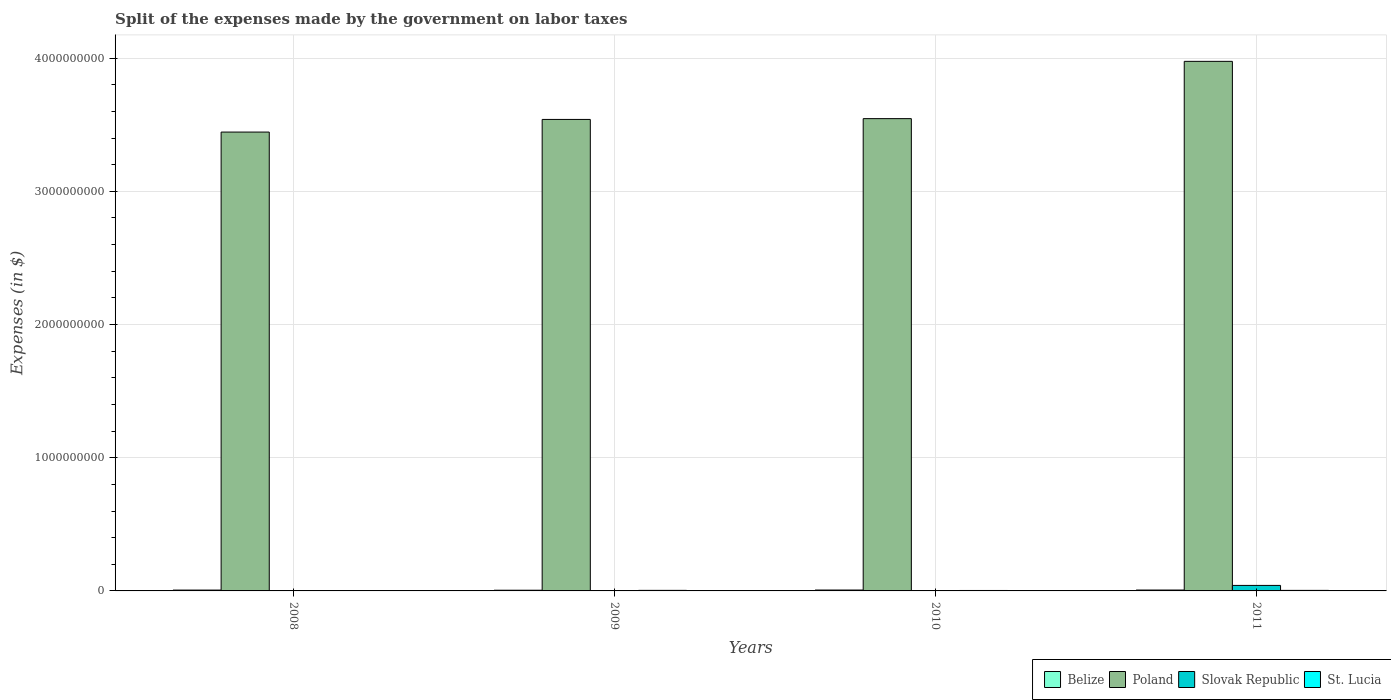Are the number of bars per tick equal to the number of legend labels?
Make the answer very short. Yes. How many bars are there on the 4th tick from the left?
Ensure brevity in your answer.  4. What is the label of the 4th group of bars from the left?
Offer a very short reply. 2011. What is the expenses made by the government on labor taxes in St. Lucia in 2008?
Offer a very short reply. 2.30e+06. Across all years, what is the maximum expenses made by the government on labor taxes in Slovak Republic?
Give a very brief answer. 4.13e+07. Across all years, what is the minimum expenses made by the government on labor taxes in Slovak Republic?
Your answer should be very brief. 3.61e+05. What is the total expenses made by the government on labor taxes in Poland in the graph?
Your response must be concise. 1.45e+1. What is the difference between the expenses made by the government on labor taxes in Belize in 2010 and that in 2011?
Keep it short and to the point. -1.03e+05. What is the difference between the expenses made by the government on labor taxes in Slovak Republic in 2011 and the expenses made by the government on labor taxes in St. Lucia in 2009?
Provide a succinct answer. 3.71e+07. What is the average expenses made by the government on labor taxes in St. Lucia per year?
Your answer should be very brief. 3.45e+06. In the year 2008, what is the difference between the expenses made by the government on labor taxes in Slovak Republic and expenses made by the government on labor taxes in Belize?
Make the answer very short. -4.93e+06. What is the ratio of the expenses made by the government on labor taxes in St. Lucia in 2010 to that in 2011?
Your answer should be compact. 0.82. Is the expenses made by the government on labor taxes in St. Lucia in 2008 less than that in 2011?
Keep it short and to the point. Yes. Is the difference between the expenses made by the government on labor taxes in Slovak Republic in 2008 and 2010 greater than the difference between the expenses made by the government on labor taxes in Belize in 2008 and 2010?
Provide a succinct answer. Yes. What is the difference between the highest and the second highest expenses made by the government on labor taxes in Slovak Republic?
Offer a very short reply. 3.99e+07. What is the difference between the highest and the lowest expenses made by the government on labor taxes in Belize?
Your answer should be very brief. 1.41e+06. Is it the case that in every year, the sum of the expenses made by the government on labor taxes in Slovak Republic and expenses made by the government on labor taxes in Poland is greater than the sum of expenses made by the government on labor taxes in St. Lucia and expenses made by the government on labor taxes in Belize?
Ensure brevity in your answer.  Yes. What does the 4th bar from the left in 2010 represents?
Keep it short and to the point. St. Lucia. What does the 4th bar from the right in 2008 represents?
Give a very brief answer. Belize. Is it the case that in every year, the sum of the expenses made by the government on labor taxes in Poland and expenses made by the government on labor taxes in Slovak Republic is greater than the expenses made by the government on labor taxes in St. Lucia?
Your answer should be compact. Yes. How many bars are there?
Keep it short and to the point. 16. Are all the bars in the graph horizontal?
Ensure brevity in your answer.  No. How many years are there in the graph?
Offer a very short reply. 4. Does the graph contain grids?
Your answer should be compact. Yes. How many legend labels are there?
Keep it short and to the point. 4. What is the title of the graph?
Offer a terse response. Split of the expenses made by the government on labor taxes. What is the label or title of the Y-axis?
Offer a very short reply. Expenses (in $). What is the Expenses (in $) in Belize in 2008?
Your answer should be compact. 6.32e+06. What is the Expenses (in $) of Poland in 2008?
Keep it short and to the point. 3.44e+09. What is the Expenses (in $) of Slovak Republic in 2008?
Offer a terse response. 1.39e+06. What is the Expenses (in $) in St. Lucia in 2008?
Provide a succinct answer. 2.30e+06. What is the Expenses (in $) in Belize in 2009?
Ensure brevity in your answer.  5.26e+06. What is the Expenses (in $) in Poland in 2009?
Provide a succinct answer. 3.54e+09. What is the Expenses (in $) of Slovak Republic in 2009?
Your answer should be compact. 7.25e+05. What is the Expenses (in $) in St. Lucia in 2009?
Keep it short and to the point. 4.20e+06. What is the Expenses (in $) of Belize in 2010?
Make the answer very short. 6.57e+06. What is the Expenses (in $) of Poland in 2010?
Ensure brevity in your answer.  3.55e+09. What is the Expenses (in $) in Slovak Republic in 2010?
Provide a succinct answer. 3.61e+05. What is the Expenses (in $) of St. Lucia in 2010?
Offer a very short reply. 3.30e+06. What is the Expenses (in $) in Belize in 2011?
Your answer should be compact. 6.67e+06. What is the Expenses (in $) in Poland in 2011?
Your answer should be compact. 3.98e+09. What is the Expenses (in $) in Slovak Republic in 2011?
Your response must be concise. 4.13e+07. What is the Expenses (in $) in St. Lucia in 2011?
Provide a succinct answer. 4.00e+06. Across all years, what is the maximum Expenses (in $) of Belize?
Your answer should be compact. 6.67e+06. Across all years, what is the maximum Expenses (in $) in Poland?
Your answer should be very brief. 3.98e+09. Across all years, what is the maximum Expenses (in $) of Slovak Republic?
Your answer should be very brief. 4.13e+07. Across all years, what is the maximum Expenses (in $) of St. Lucia?
Ensure brevity in your answer.  4.20e+06. Across all years, what is the minimum Expenses (in $) of Belize?
Provide a short and direct response. 5.26e+06. Across all years, what is the minimum Expenses (in $) of Poland?
Your answer should be compact. 3.44e+09. Across all years, what is the minimum Expenses (in $) in Slovak Republic?
Provide a short and direct response. 3.61e+05. Across all years, what is the minimum Expenses (in $) of St. Lucia?
Your answer should be very brief. 2.30e+06. What is the total Expenses (in $) in Belize in the graph?
Your answer should be very brief. 2.48e+07. What is the total Expenses (in $) of Poland in the graph?
Your answer should be compact. 1.45e+1. What is the total Expenses (in $) of Slovak Republic in the graph?
Your answer should be compact. 4.38e+07. What is the total Expenses (in $) of St. Lucia in the graph?
Ensure brevity in your answer.  1.38e+07. What is the difference between the Expenses (in $) of Belize in 2008 and that in 2009?
Provide a succinct answer. 1.06e+06. What is the difference between the Expenses (in $) of Poland in 2008 and that in 2009?
Your response must be concise. -9.50e+07. What is the difference between the Expenses (in $) of Slovak Republic in 2008 and that in 2009?
Give a very brief answer. 6.67e+05. What is the difference between the Expenses (in $) of St. Lucia in 2008 and that in 2009?
Keep it short and to the point. -1.90e+06. What is the difference between the Expenses (in $) of Belize in 2008 and that in 2010?
Make the answer very short. -2.47e+05. What is the difference between the Expenses (in $) in Poland in 2008 and that in 2010?
Offer a very short reply. -1.01e+08. What is the difference between the Expenses (in $) of Slovak Republic in 2008 and that in 2010?
Provide a short and direct response. 1.03e+06. What is the difference between the Expenses (in $) of Belize in 2008 and that in 2011?
Provide a succinct answer. -3.50e+05. What is the difference between the Expenses (in $) of Poland in 2008 and that in 2011?
Provide a succinct answer. -5.31e+08. What is the difference between the Expenses (in $) of Slovak Republic in 2008 and that in 2011?
Your answer should be very brief. -3.99e+07. What is the difference between the Expenses (in $) of St. Lucia in 2008 and that in 2011?
Keep it short and to the point. -1.70e+06. What is the difference between the Expenses (in $) in Belize in 2009 and that in 2010?
Give a very brief answer. -1.31e+06. What is the difference between the Expenses (in $) of Poland in 2009 and that in 2010?
Keep it short and to the point. -6.00e+06. What is the difference between the Expenses (in $) in Slovak Republic in 2009 and that in 2010?
Make the answer very short. 3.64e+05. What is the difference between the Expenses (in $) in Belize in 2009 and that in 2011?
Ensure brevity in your answer.  -1.41e+06. What is the difference between the Expenses (in $) of Poland in 2009 and that in 2011?
Offer a terse response. -4.36e+08. What is the difference between the Expenses (in $) in Slovak Republic in 2009 and that in 2011?
Ensure brevity in your answer.  -4.06e+07. What is the difference between the Expenses (in $) of St. Lucia in 2009 and that in 2011?
Keep it short and to the point. 2.00e+05. What is the difference between the Expenses (in $) of Belize in 2010 and that in 2011?
Ensure brevity in your answer.  -1.03e+05. What is the difference between the Expenses (in $) of Poland in 2010 and that in 2011?
Ensure brevity in your answer.  -4.30e+08. What is the difference between the Expenses (in $) in Slovak Republic in 2010 and that in 2011?
Offer a very short reply. -4.10e+07. What is the difference between the Expenses (in $) in St. Lucia in 2010 and that in 2011?
Keep it short and to the point. -7.00e+05. What is the difference between the Expenses (in $) of Belize in 2008 and the Expenses (in $) of Poland in 2009?
Your answer should be very brief. -3.53e+09. What is the difference between the Expenses (in $) in Belize in 2008 and the Expenses (in $) in Slovak Republic in 2009?
Your answer should be very brief. 5.60e+06. What is the difference between the Expenses (in $) in Belize in 2008 and the Expenses (in $) in St. Lucia in 2009?
Your answer should be compact. 2.12e+06. What is the difference between the Expenses (in $) in Poland in 2008 and the Expenses (in $) in Slovak Republic in 2009?
Offer a terse response. 3.44e+09. What is the difference between the Expenses (in $) in Poland in 2008 and the Expenses (in $) in St. Lucia in 2009?
Provide a succinct answer. 3.44e+09. What is the difference between the Expenses (in $) in Slovak Republic in 2008 and the Expenses (in $) in St. Lucia in 2009?
Your response must be concise. -2.81e+06. What is the difference between the Expenses (in $) of Belize in 2008 and the Expenses (in $) of Poland in 2010?
Your answer should be compact. -3.54e+09. What is the difference between the Expenses (in $) in Belize in 2008 and the Expenses (in $) in Slovak Republic in 2010?
Keep it short and to the point. 5.96e+06. What is the difference between the Expenses (in $) of Belize in 2008 and the Expenses (in $) of St. Lucia in 2010?
Keep it short and to the point. 3.02e+06. What is the difference between the Expenses (in $) in Poland in 2008 and the Expenses (in $) in Slovak Republic in 2010?
Make the answer very short. 3.44e+09. What is the difference between the Expenses (in $) in Poland in 2008 and the Expenses (in $) in St. Lucia in 2010?
Provide a short and direct response. 3.44e+09. What is the difference between the Expenses (in $) of Slovak Republic in 2008 and the Expenses (in $) of St. Lucia in 2010?
Your answer should be compact. -1.91e+06. What is the difference between the Expenses (in $) in Belize in 2008 and the Expenses (in $) in Poland in 2011?
Your answer should be compact. -3.97e+09. What is the difference between the Expenses (in $) of Belize in 2008 and the Expenses (in $) of Slovak Republic in 2011?
Give a very brief answer. -3.50e+07. What is the difference between the Expenses (in $) in Belize in 2008 and the Expenses (in $) in St. Lucia in 2011?
Offer a terse response. 2.32e+06. What is the difference between the Expenses (in $) of Poland in 2008 and the Expenses (in $) of Slovak Republic in 2011?
Offer a very short reply. 3.40e+09. What is the difference between the Expenses (in $) in Poland in 2008 and the Expenses (in $) in St. Lucia in 2011?
Provide a succinct answer. 3.44e+09. What is the difference between the Expenses (in $) in Slovak Republic in 2008 and the Expenses (in $) in St. Lucia in 2011?
Provide a succinct answer. -2.61e+06. What is the difference between the Expenses (in $) in Belize in 2009 and the Expenses (in $) in Poland in 2010?
Ensure brevity in your answer.  -3.54e+09. What is the difference between the Expenses (in $) in Belize in 2009 and the Expenses (in $) in Slovak Republic in 2010?
Your answer should be compact. 4.90e+06. What is the difference between the Expenses (in $) in Belize in 2009 and the Expenses (in $) in St. Lucia in 2010?
Ensure brevity in your answer.  1.96e+06. What is the difference between the Expenses (in $) in Poland in 2009 and the Expenses (in $) in Slovak Republic in 2010?
Offer a terse response. 3.54e+09. What is the difference between the Expenses (in $) in Poland in 2009 and the Expenses (in $) in St. Lucia in 2010?
Keep it short and to the point. 3.54e+09. What is the difference between the Expenses (in $) in Slovak Republic in 2009 and the Expenses (in $) in St. Lucia in 2010?
Ensure brevity in your answer.  -2.58e+06. What is the difference between the Expenses (in $) in Belize in 2009 and the Expenses (in $) in Poland in 2011?
Make the answer very short. -3.97e+09. What is the difference between the Expenses (in $) of Belize in 2009 and the Expenses (in $) of Slovak Republic in 2011?
Give a very brief answer. -3.61e+07. What is the difference between the Expenses (in $) in Belize in 2009 and the Expenses (in $) in St. Lucia in 2011?
Your response must be concise. 1.26e+06. What is the difference between the Expenses (in $) in Poland in 2009 and the Expenses (in $) in Slovak Republic in 2011?
Ensure brevity in your answer.  3.50e+09. What is the difference between the Expenses (in $) in Poland in 2009 and the Expenses (in $) in St. Lucia in 2011?
Your answer should be very brief. 3.54e+09. What is the difference between the Expenses (in $) of Slovak Republic in 2009 and the Expenses (in $) of St. Lucia in 2011?
Provide a succinct answer. -3.28e+06. What is the difference between the Expenses (in $) in Belize in 2010 and the Expenses (in $) in Poland in 2011?
Ensure brevity in your answer.  -3.97e+09. What is the difference between the Expenses (in $) of Belize in 2010 and the Expenses (in $) of Slovak Republic in 2011?
Offer a very short reply. -3.48e+07. What is the difference between the Expenses (in $) in Belize in 2010 and the Expenses (in $) in St. Lucia in 2011?
Your answer should be very brief. 2.57e+06. What is the difference between the Expenses (in $) of Poland in 2010 and the Expenses (in $) of Slovak Republic in 2011?
Offer a terse response. 3.50e+09. What is the difference between the Expenses (in $) in Poland in 2010 and the Expenses (in $) in St. Lucia in 2011?
Your answer should be very brief. 3.54e+09. What is the difference between the Expenses (in $) of Slovak Republic in 2010 and the Expenses (in $) of St. Lucia in 2011?
Make the answer very short. -3.64e+06. What is the average Expenses (in $) in Belize per year?
Your answer should be compact. 6.21e+06. What is the average Expenses (in $) of Poland per year?
Your answer should be compact. 3.63e+09. What is the average Expenses (in $) of Slovak Republic per year?
Provide a short and direct response. 1.10e+07. What is the average Expenses (in $) in St. Lucia per year?
Your response must be concise. 3.45e+06. In the year 2008, what is the difference between the Expenses (in $) in Belize and Expenses (in $) in Poland?
Give a very brief answer. -3.44e+09. In the year 2008, what is the difference between the Expenses (in $) in Belize and Expenses (in $) in Slovak Republic?
Your response must be concise. 4.93e+06. In the year 2008, what is the difference between the Expenses (in $) in Belize and Expenses (in $) in St. Lucia?
Offer a very short reply. 4.02e+06. In the year 2008, what is the difference between the Expenses (in $) in Poland and Expenses (in $) in Slovak Republic?
Keep it short and to the point. 3.44e+09. In the year 2008, what is the difference between the Expenses (in $) in Poland and Expenses (in $) in St. Lucia?
Your response must be concise. 3.44e+09. In the year 2008, what is the difference between the Expenses (in $) in Slovak Republic and Expenses (in $) in St. Lucia?
Keep it short and to the point. -9.08e+05. In the year 2009, what is the difference between the Expenses (in $) in Belize and Expenses (in $) in Poland?
Your answer should be compact. -3.53e+09. In the year 2009, what is the difference between the Expenses (in $) of Belize and Expenses (in $) of Slovak Republic?
Make the answer very short. 4.54e+06. In the year 2009, what is the difference between the Expenses (in $) of Belize and Expenses (in $) of St. Lucia?
Your answer should be very brief. 1.06e+06. In the year 2009, what is the difference between the Expenses (in $) of Poland and Expenses (in $) of Slovak Republic?
Keep it short and to the point. 3.54e+09. In the year 2009, what is the difference between the Expenses (in $) of Poland and Expenses (in $) of St. Lucia?
Keep it short and to the point. 3.54e+09. In the year 2009, what is the difference between the Expenses (in $) in Slovak Republic and Expenses (in $) in St. Lucia?
Your answer should be compact. -3.48e+06. In the year 2010, what is the difference between the Expenses (in $) in Belize and Expenses (in $) in Poland?
Keep it short and to the point. -3.54e+09. In the year 2010, what is the difference between the Expenses (in $) in Belize and Expenses (in $) in Slovak Republic?
Ensure brevity in your answer.  6.21e+06. In the year 2010, what is the difference between the Expenses (in $) in Belize and Expenses (in $) in St. Lucia?
Provide a short and direct response. 3.27e+06. In the year 2010, what is the difference between the Expenses (in $) of Poland and Expenses (in $) of Slovak Republic?
Give a very brief answer. 3.55e+09. In the year 2010, what is the difference between the Expenses (in $) of Poland and Expenses (in $) of St. Lucia?
Make the answer very short. 3.54e+09. In the year 2010, what is the difference between the Expenses (in $) of Slovak Republic and Expenses (in $) of St. Lucia?
Your answer should be very brief. -2.94e+06. In the year 2011, what is the difference between the Expenses (in $) in Belize and Expenses (in $) in Poland?
Ensure brevity in your answer.  -3.97e+09. In the year 2011, what is the difference between the Expenses (in $) in Belize and Expenses (in $) in Slovak Republic?
Make the answer very short. -3.47e+07. In the year 2011, what is the difference between the Expenses (in $) of Belize and Expenses (in $) of St. Lucia?
Keep it short and to the point. 2.67e+06. In the year 2011, what is the difference between the Expenses (in $) in Poland and Expenses (in $) in Slovak Republic?
Provide a succinct answer. 3.93e+09. In the year 2011, what is the difference between the Expenses (in $) in Poland and Expenses (in $) in St. Lucia?
Offer a very short reply. 3.97e+09. In the year 2011, what is the difference between the Expenses (in $) in Slovak Republic and Expenses (in $) in St. Lucia?
Provide a short and direct response. 3.73e+07. What is the ratio of the Expenses (in $) of Belize in 2008 to that in 2009?
Offer a very short reply. 1.2. What is the ratio of the Expenses (in $) of Poland in 2008 to that in 2009?
Keep it short and to the point. 0.97. What is the ratio of the Expenses (in $) of Slovak Republic in 2008 to that in 2009?
Give a very brief answer. 1.92. What is the ratio of the Expenses (in $) in St. Lucia in 2008 to that in 2009?
Provide a short and direct response. 0.55. What is the ratio of the Expenses (in $) of Belize in 2008 to that in 2010?
Offer a terse response. 0.96. What is the ratio of the Expenses (in $) of Poland in 2008 to that in 2010?
Provide a succinct answer. 0.97. What is the ratio of the Expenses (in $) in Slovak Republic in 2008 to that in 2010?
Give a very brief answer. 3.85. What is the ratio of the Expenses (in $) in St. Lucia in 2008 to that in 2010?
Ensure brevity in your answer.  0.7. What is the ratio of the Expenses (in $) in Belize in 2008 to that in 2011?
Your answer should be very brief. 0.95. What is the ratio of the Expenses (in $) in Poland in 2008 to that in 2011?
Offer a very short reply. 0.87. What is the ratio of the Expenses (in $) of Slovak Republic in 2008 to that in 2011?
Provide a succinct answer. 0.03. What is the ratio of the Expenses (in $) in St. Lucia in 2008 to that in 2011?
Keep it short and to the point. 0.57. What is the ratio of the Expenses (in $) of Belize in 2009 to that in 2010?
Your answer should be very brief. 0.8. What is the ratio of the Expenses (in $) of Poland in 2009 to that in 2010?
Ensure brevity in your answer.  1. What is the ratio of the Expenses (in $) in Slovak Republic in 2009 to that in 2010?
Provide a short and direct response. 2.01. What is the ratio of the Expenses (in $) in St. Lucia in 2009 to that in 2010?
Your response must be concise. 1.27. What is the ratio of the Expenses (in $) of Belize in 2009 to that in 2011?
Provide a succinct answer. 0.79. What is the ratio of the Expenses (in $) in Poland in 2009 to that in 2011?
Your response must be concise. 0.89. What is the ratio of the Expenses (in $) of Slovak Republic in 2009 to that in 2011?
Your answer should be compact. 0.02. What is the ratio of the Expenses (in $) of St. Lucia in 2009 to that in 2011?
Your response must be concise. 1.05. What is the ratio of the Expenses (in $) of Belize in 2010 to that in 2011?
Your answer should be compact. 0.98. What is the ratio of the Expenses (in $) in Poland in 2010 to that in 2011?
Your answer should be very brief. 0.89. What is the ratio of the Expenses (in $) in Slovak Republic in 2010 to that in 2011?
Your response must be concise. 0.01. What is the ratio of the Expenses (in $) of St. Lucia in 2010 to that in 2011?
Your response must be concise. 0.82. What is the difference between the highest and the second highest Expenses (in $) of Belize?
Give a very brief answer. 1.03e+05. What is the difference between the highest and the second highest Expenses (in $) of Poland?
Give a very brief answer. 4.30e+08. What is the difference between the highest and the second highest Expenses (in $) of Slovak Republic?
Make the answer very short. 3.99e+07. What is the difference between the highest and the second highest Expenses (in $) in St. Lucia?
Offer a terse response. 2.00e+05. What is the difference between the highest and the lowest Expenses (in $) of Belize?
Your answer should be very brief. 1.41e+06. What is the difference between the highest and the lowest Expenses (in $) in Poland?
Give a very brief answer. 5.31e+08. What is the difference between the highest and the lowest Expenses (in $) of Slovak Republic?
Your answer should be compact. 4.10e+07. What is the difference between the highest and the lowest Expenses (in $) of St. Lucia?
Keep it short and to the point. 1.90e+06. 